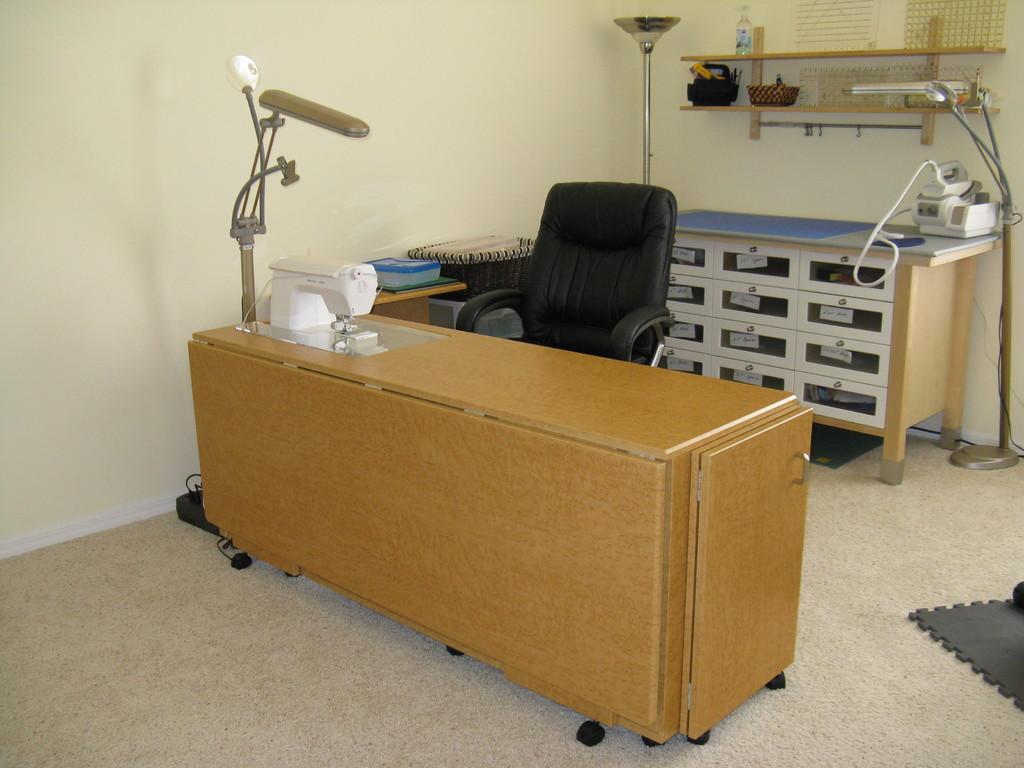Please provide a concise description of this image. In this image I can see a chair, a desk, a machine, few lamps and a cupboard. 